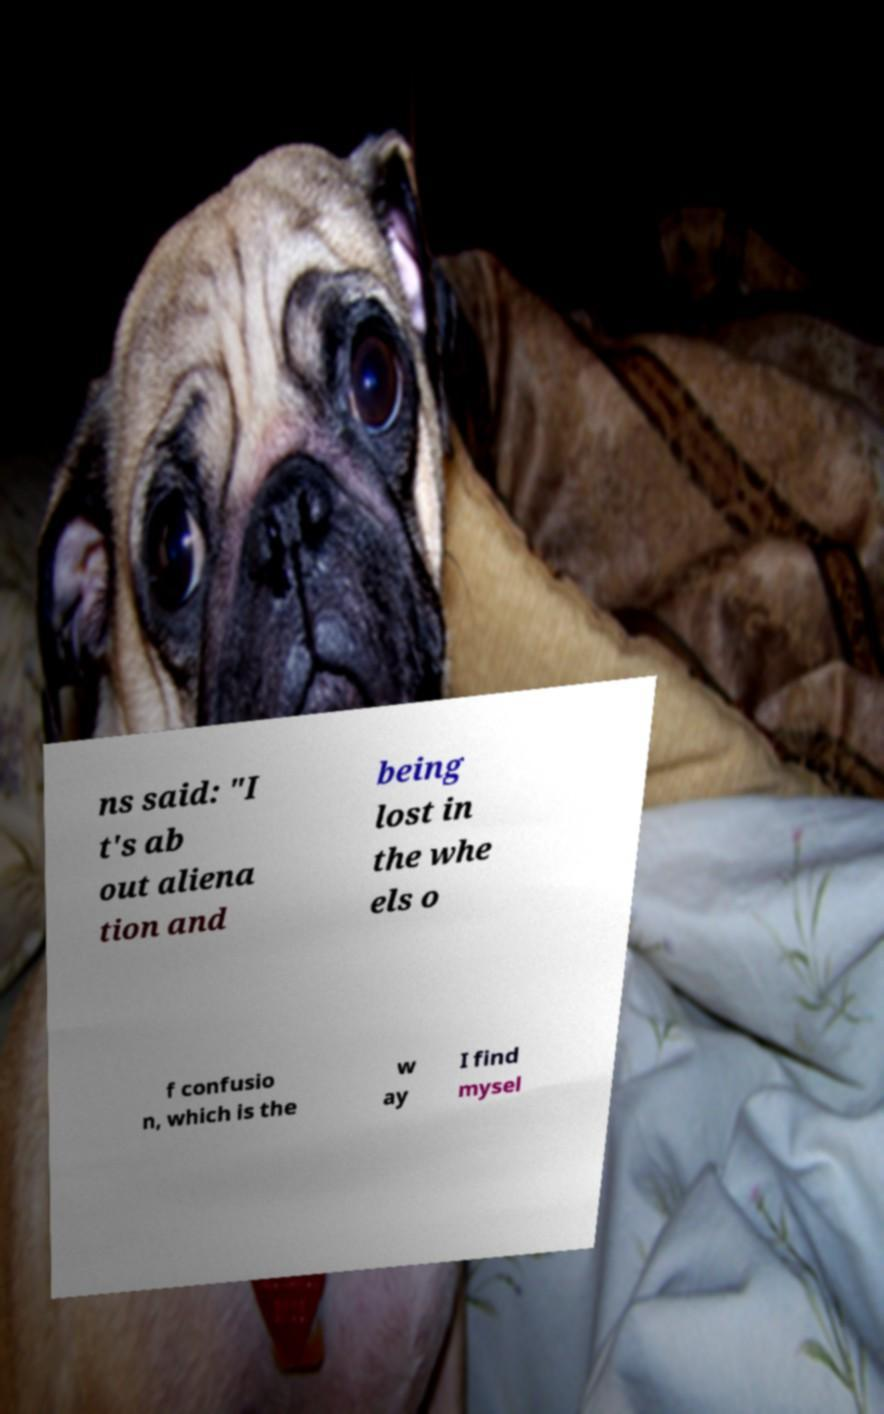Please identify and transcribe the text found in this image. ns said: "I t's ab out aliena tion and being lost in the whe els o f confusio n, which is the w ay I find mysel 